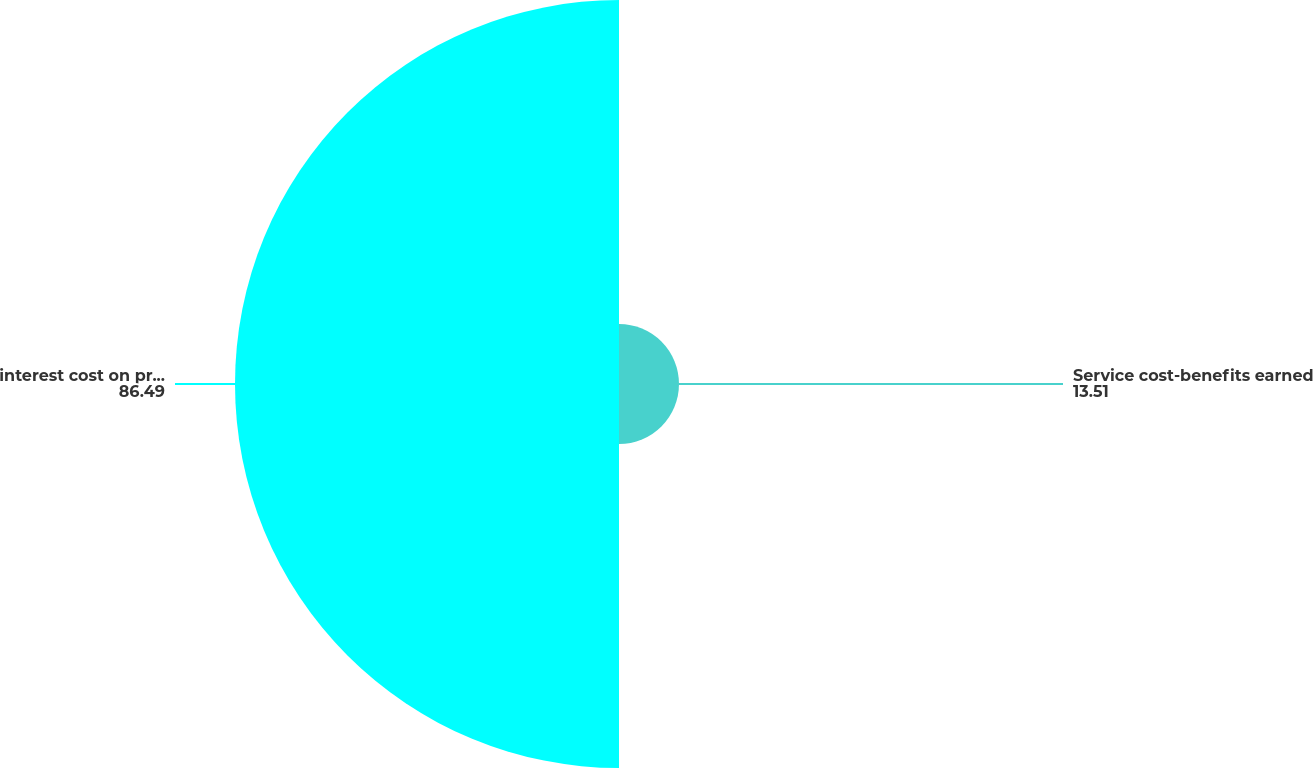Convert chart. <chart><loc_0><loc_0><loc_500><loc_500><pie_chart><fcel>Service cost-benefits earned<fcel>interest cost on projected<nl><fcel>13.51%<fcel>86.49%<nl></chart> 